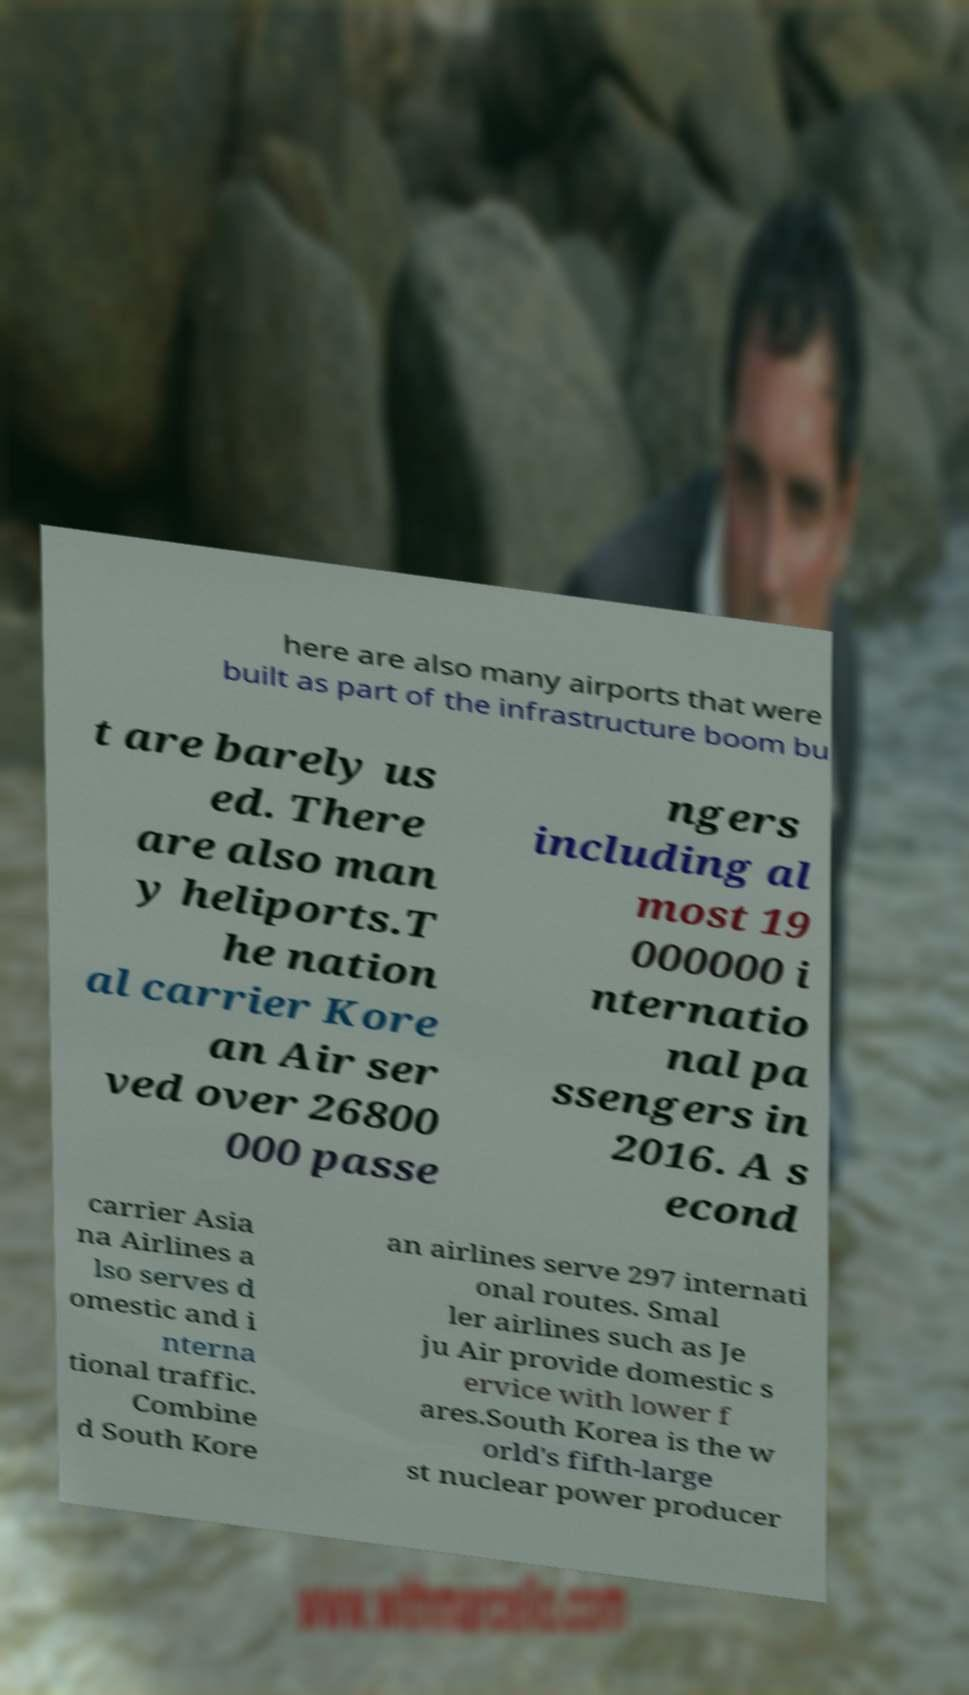Please identify and transcribe the text found in this image. here are also many airports that were built as part of the infrastructure boom bu t are barely us ed. There are also man y heliports.T he nation al carrier Kore an Air ser ved over 26800 000 passe ngers including al most 19 000000 i nternatio nal pa ssengers in 2016. A s econd carrier Asia na Airlines a lso serves d omestic and i nterna tional traffic. Combine d South Kore an airlines serve 297 internati onal routes. Smal ler airlines such as Je ju Air provide domestic s ervice with lower f ares.South Korea is the w orld's fifth-large st nuclear power producer 